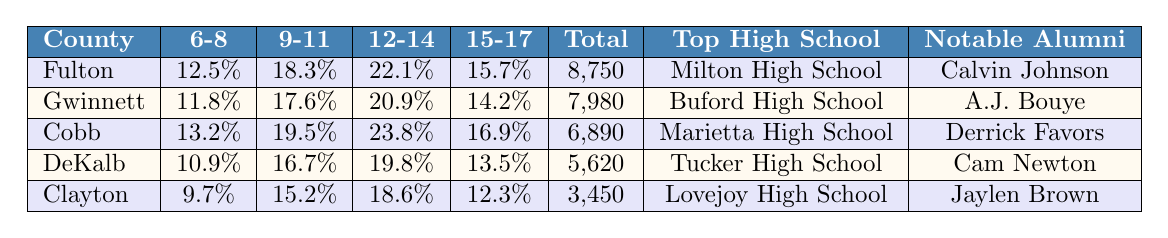What is the participation rate for 12-14 year olds in Fulton County? The table shows that the participation rate for the age group 12-14 in Fulton County is 22.1%.
Answer: 22.1% Which county has the highest total number of youth football participants? The total participants for each county are listed, and Fulton County has the highest total at 8,750.
Answer: Fulton What is the average participation rate for the age group 6-8 across all counties? To calculate the average for age group 6-8, add the rates: (12.5 + 11.8 + 13.2 + 10.9 + 9.7) = 58.1. Divide by 5 (the number of counties): 58.1 / 5 = 11.62.
Answer: 11.62% Is the participation rate for 9-11 year olds in Cobb County higher than in Gwinnett County? The participation rates are 19.5% for Cobb and 17.6% for Gwinnett. Since 19.5% is greater than 17.6%, the answer is yes.
Answer: Yes What is the difference in participation rates for the age group 15-17 between Cobb and Clayton counties? The participation rate for Cobb is 16.9% and for Clayton is 12.3%. The difference is calculated as 16.9 - 12.3 = 4.6%.
Answer: 4.6% Which county has the lowest participation rate for the age group 6-8 and what is that rate? The table shows that Clayton County has the lowest participation rate for 6-8 year olds at 9.7%.
Answer: Clayton, 9.7% What is the total participation rate for 12-14 year olds across all counties? To find the total, add the rates for 12-14 year olds: (22.1 + 20.9 + 23.8 + 19.8 + 18.6) = 105.2%.
Answer: 105.2% Are there any counties where the 15-17 age group's participation rate is below 14%? By examining the rates, DeKalb is at 13.5% and Clayton is at 12.3%, both below 14%. Therefore, the answer is yes.
Answer: Yes Which county with the highest participation rate for the age group 12-14 also has a notable NFL alumni? Cobb County has the highest participation rate for 12-14 year olds at 23.8% and its notable alumnus is Derrick Favors.
Answer: Cobb, Derrick Favors How many counties have a total participant number greater than 6,000? The counties with total participants greater than 6,000 are Fulton (8,750), Gwinnett (7,980), and Cobb (6,890). This means there are three counties.
Answer: 3 